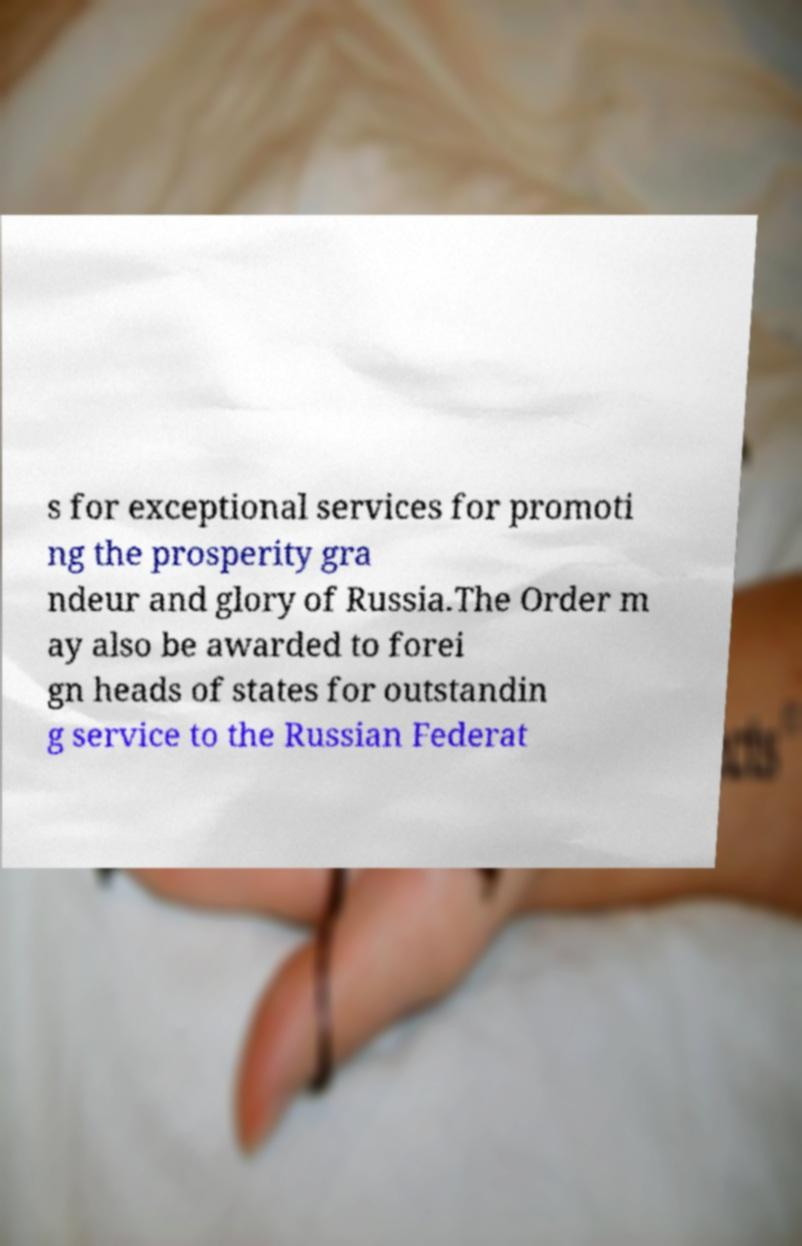What messages or text are displayed in this image? I need them in a readable, typed format. s for exceptional services for promoti ng the prosperity gra ndeur and glory of Russia.The Order m ay also be awarded to forei gn heads of states for outstandin g service to the Russian Federat 